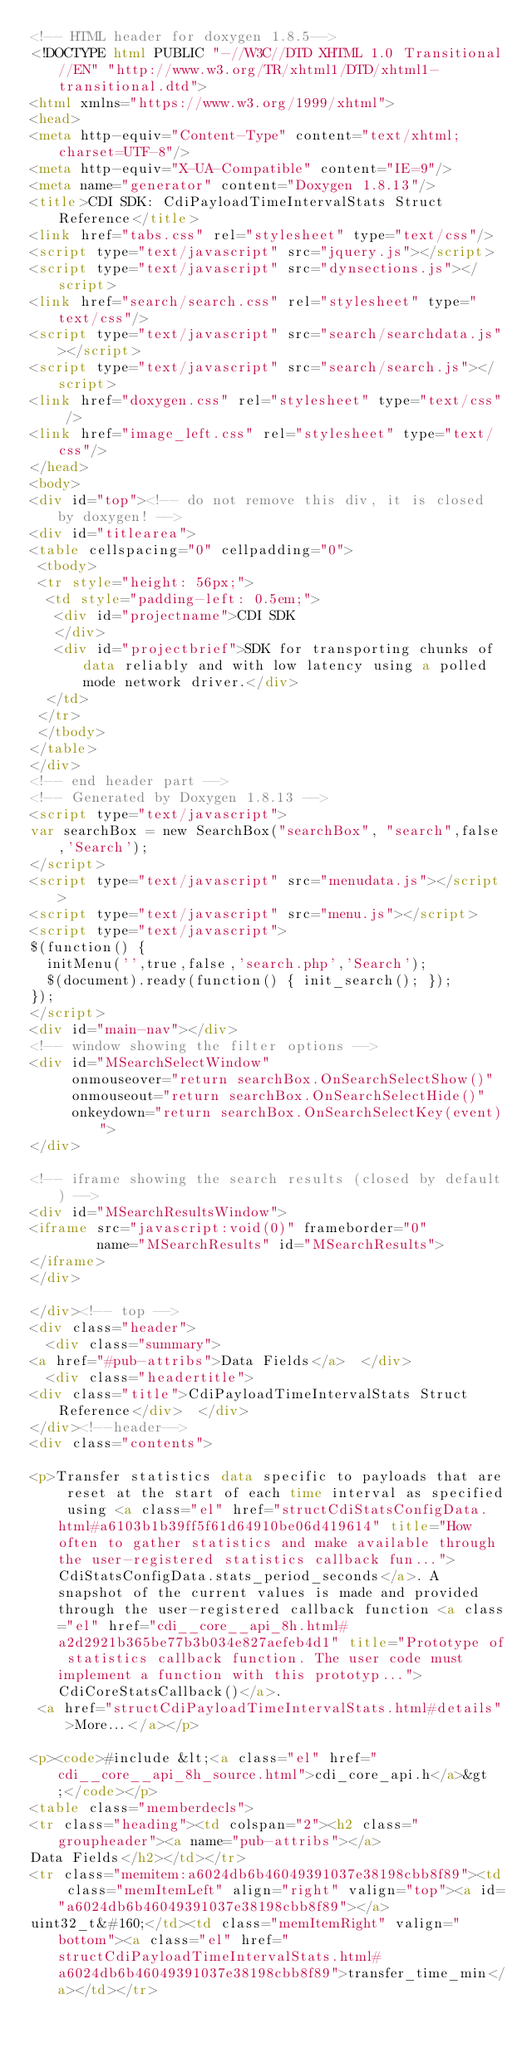<code> <loc_0><loc_0><loc_500><loc_500><_HTML_><!-- HTML header for doxygen 1.8.5-->
<!DOCTYPE html PUBLIC "-//W3C//DTD XHTML 1.0 Transitional//EN" "http://www.w3.org/TR/xhtml1/DTD/xhtml1-transitional.dtd">
<html xmlns="https://www.w3.org/1999/xhtml">
<head>
<meta http-equiv="Content-Type" content="text/xhtml;charset=UTF-8"/>
<meta http-equiv="X-UA-Compatible" content="IE=9"/>
<meta name="generator" content="Doxygen 1.8.13"/>
<title>CDI SDK: CdiPayloadTimeIntervalStats Struct Reference</title>
<link href="tabs.css" rel="stylesheet" type="text/css"/>
<script type="text/javascript" src="jquery.js"></script>
<script type="text/javascript" src="dynsections.js"></script>
<link href="search/search.css" rel="stylesheet" type="text/css"/>
<script type="text/javascript" src="search/searchdata.js"></script>
<script type="text/javascript" src="search/search.js"></script>
<link href="doxygen.css" rel="stylesheet" type="text/css" />
<link href="image_left.css" rel="stylesheet" type="text/css"/>
</head>
<body>
<div id="top"><!-- do not remove this div, it is closed by doxygen! -->
<div id="titlearea">
<table cellspacing="0" cellpadding="0">
 <tbody>
 <tr style="height: 56px;">
  <td style="padding-left: 0.5em;">
   <div id="projectname">CDI SDK
   </div>
   <div id="projectbrief">SDK for transporting chunks of data reliably and with low latency using a polled mode network driver.</div>
  </td>
 </tr>
 </tbody>
</table>
</div>
<!-- end header part -->
<!-- Generated by Doxygen 1.8.13 -->
<script type="text/javascript">
var searchBox = new SearchBox("searchBox", "search",false,'Search');
</script>
<script type="text/javascript" src="menudata.js"></script>
<script type="text/javascript" src="menu.js"></script>
<script type="text/javascript">
$(function() {
  initMenu('',true,false,'search.php','Search');
  $(document).ready(function() { init_search(); });
});
</script>
<div id="main-nav"></div>
<!-- window showing the filter options -->
<div id="MSearchSelectWindow"
     onmouseover="return searchBox.OnSearchSelectShow()"
     onmouseout="return searchBox.OnSearchSelectHide()"
     onkeydown="return searchBox.OnSearchSelectKey(event)">
</div>

<!-- iframe showing the search results (closed by default) -->
<div id="MSearchResultsWindow">
<iframe src="javascript:void(0)" frameborder="0" 
        name="MSearchResults" id="MSearchResults">
</iframe>
</div>

</div><!-- top -->
<div class="header">
  <div class="summary">
<a href="#pub-attribs">Data Fields</a>  </div>
  <div class="headertitle">
<div class="title">CdiPayloadTimeIntervalStats Struct Reference</div>  </div>
</div><!--header-->
<div class="contents">

<p>Transfer statistics data specific to payloads that are reset at the start of each time interval as specified using <a class="el" href="structCdiStatsConfigData.html#a6103b1b39ff5f61d64910be06d419614" title="How often to gather statistics and make available through the user-registered statistics callback fun...">CdiStatsConfigData.stats_period_seconds</a>. A snapshot of the current values is made and provided through the user-registered callback function <a class="el" href="cdi__core__api_8h.html#a2d2921b365be77b3b034e827aefeb4d1" title="Prototype of statistics callback function. The user code must implement a function with this prototyp...">CdiCoreStatsCallback()</a>.  
 <a href="structCdiPayloadTimeIntervalStats.html#details">More...</a></p>

<p><code>#include &lt;<a class="el" href="cdi__core__api_8h_source.html">cdi_core_api.h</a>&gt;</code></p>
<table class="memberdecls">
<tr class="heading"><td colspan="2"><h2 class="groupheader"><a name="pub-attribs"></a>
Data Fields</h2></td></tr>
<tr class="memitem:a6024db6b46049391037e38198cbb8f89"><td class="memItemLeft" align="right" valign="top"><a id="a6024db6b46049391037e38198cbb8f89"></a>
uint32_t&#160;</td><td class="memItemRight" valign="bottom"><a class="el" href="structCdiPayloadTimeIntervalStats.html#a6024db6b46049391037e38198cbb8f89">transfer_time_min</a></td></tr></code> 